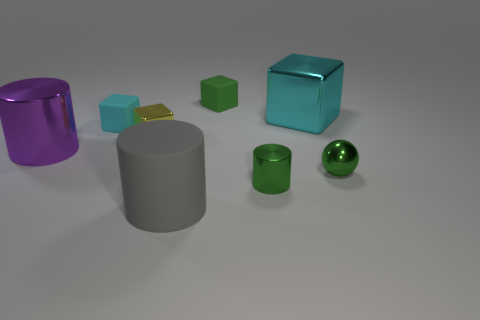There is a cyan object right of the tiny green matte block; is its size the same as the cyan cube that is on the left side of the yellow block?
Provide a succinct answer. No. What number of other objects are the same material as the large gray thing?
Provide a short and direct response. 2. Are there more gray objects that are in front of the large rubber object than small yellow objects in front of the small cylinder?
Your answer should be very brief. No. What is the large cylinder that is in front of the green sphere made of?
Provide a succinct answer. Rubber. Is the shape of the yellow metal object the same as the gray rubber object?
Offer a very short reply. No. Are there any other things that are the same color as the big metallic block?
Make the answer very short. Yes. What color is the other big object that is the same shape as the gray matte object?
Offer a terse response. Purple. Is the number of green balls that are behind the metal ball greater than the number of large matte blocks?
Your response must be concise. No. What is the color of the block to the right of the green matte cube?
Offer a very short reply. Cyan. Is the size of the green rubber thing the same as the purple shiny thing?
Your answer should be very brief. No. 